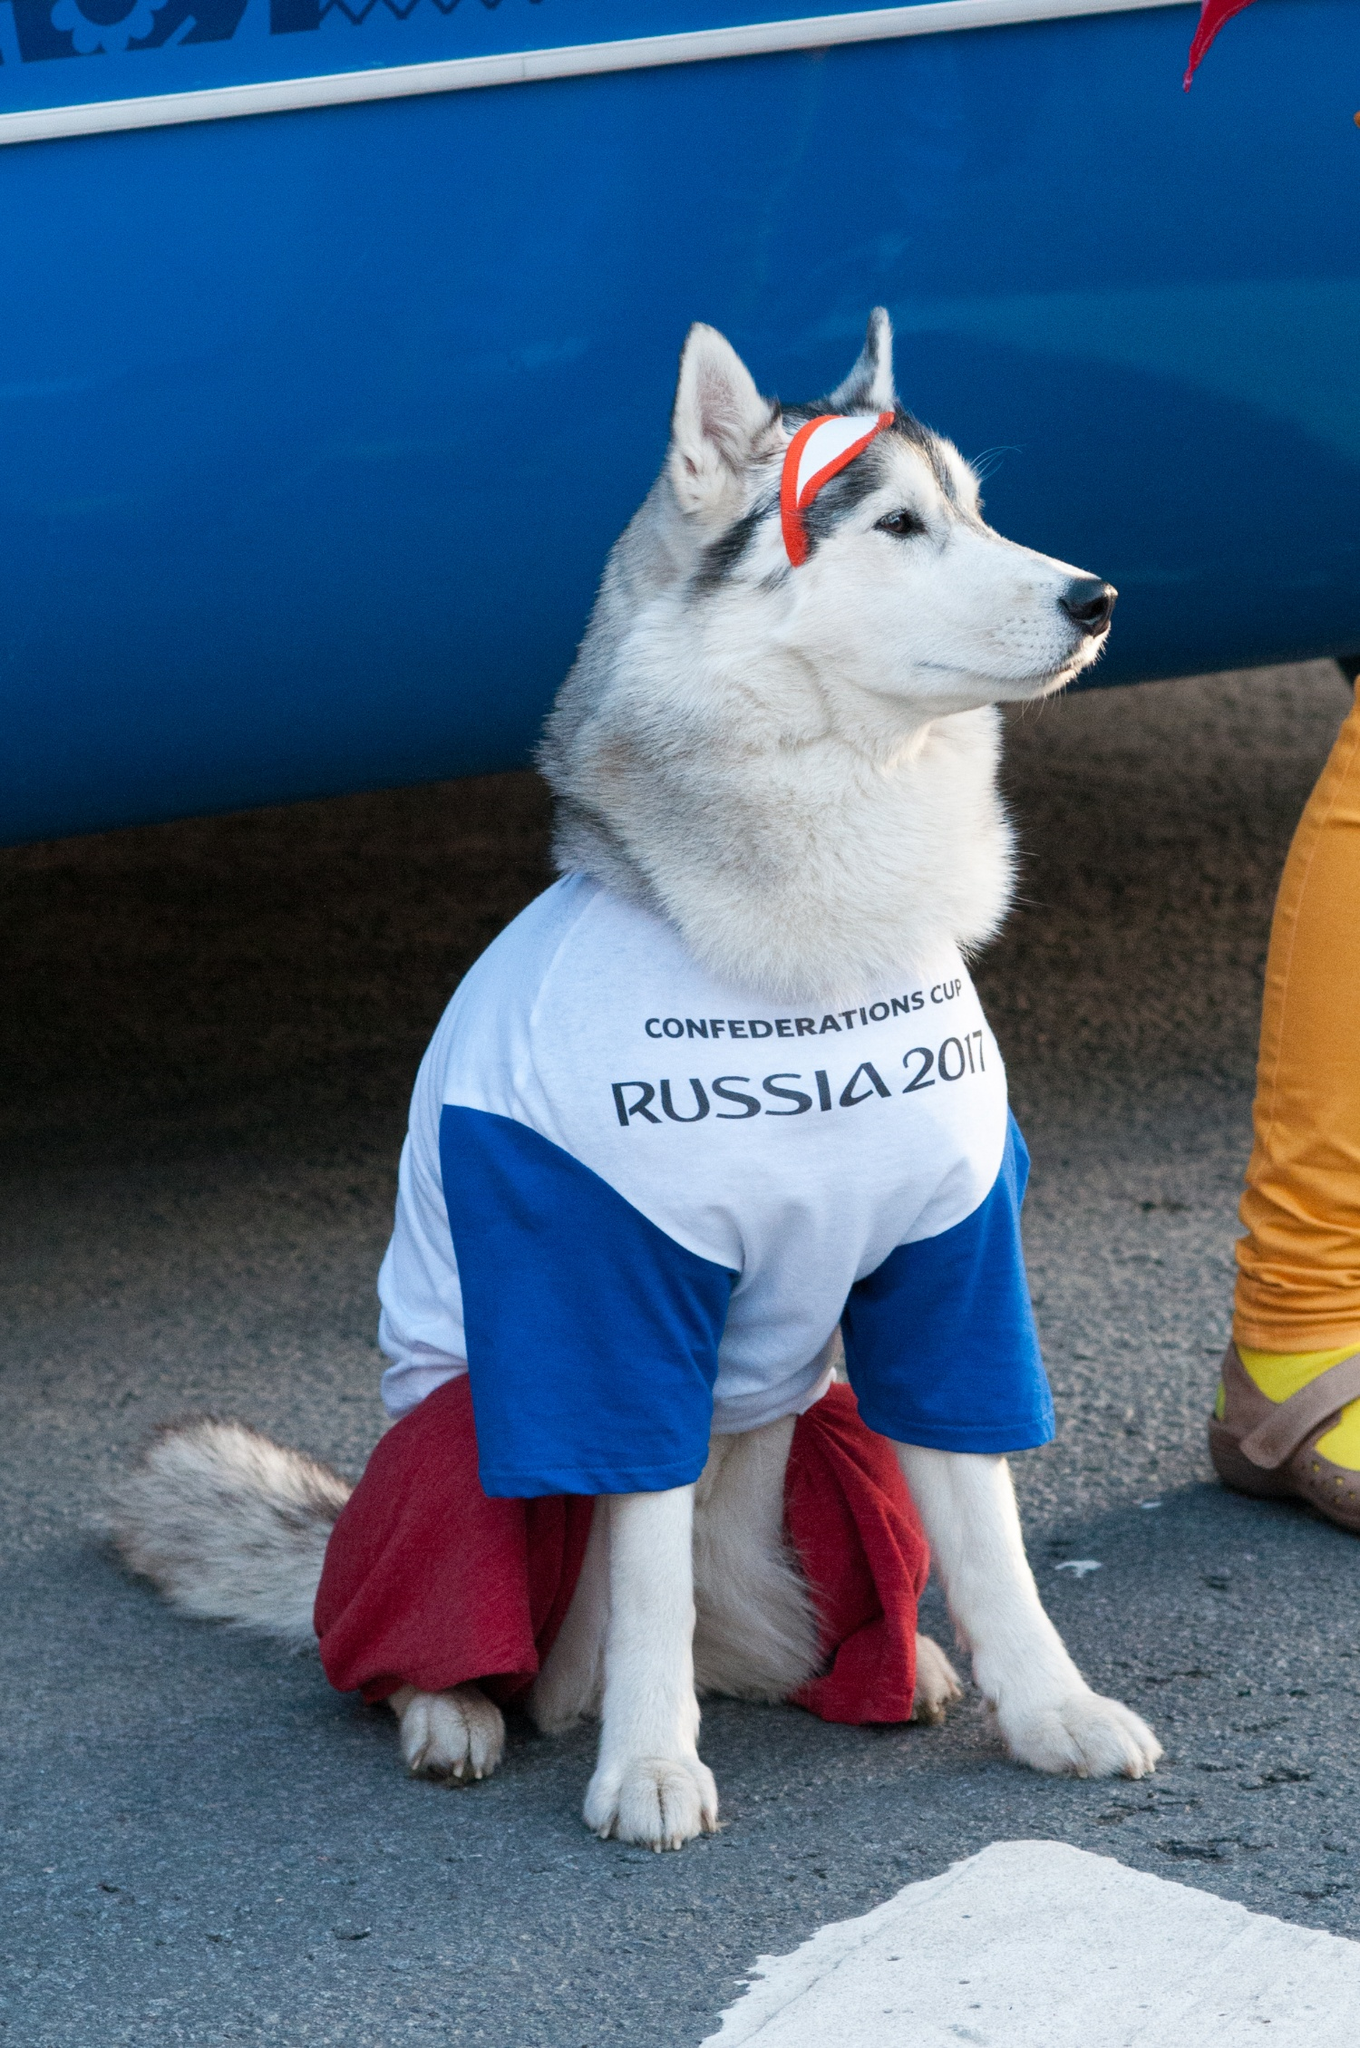What specific features make the dog the focal point in this image? The dog's vibrant attire, including the white t-shirt with blue sleeves, red pants, and red headband, draws immediate attention. Its calm and regal posture, sitting at the center with a blue banner backdrop, emphasizes its prominence. The colorful contrast between its clothing and fur, along with the minimal distractions in the background, make the dog a clear focal point. What role do you think the dog is playing in this event? The dog appears to be playing the role of a mascot or an ambassador for the Confederations Cup event. Its themed attire and positioning in front of the blue banner suggest it is there to entertain and engage with event attendees, adding a unique and memorable element to the celebration. Imagine a fantasy scenario where the dog is a hero of an epic adventure at the event. Describe it in detail. In a parallel universe where the Confederations Cup is more than just a sporting event, our hero, the Siberian Husky named 'Lunaris,' dons the enchanted attire of the ancient guardians. As the festival kicks off, Lunaris senses an impending threat—a shadowy figure aiming to steal the event's cherished trophy. With its keen senses and agile movements, Lunaris embarks on an adventure across the bustling streets and colorful stalls. The crowd cheers as Lunaris leaps through the air, tail flicking with determination. Guided by ancient symbols hidden within the festival's decor, the brave Husky tracks the thief to an abandoned warehouse. There, a thrilling chase ensues amidst towering crates and winding corridors. At the climax of the adventure, Lunaris apprehends the culprit, ensuring the safety of the trophy and restoring joy to the celebration. The crowd hails Lunaris as the true hero of the day, bringing the spirit of unity and festivity back to the Confederations Cup 2017. 